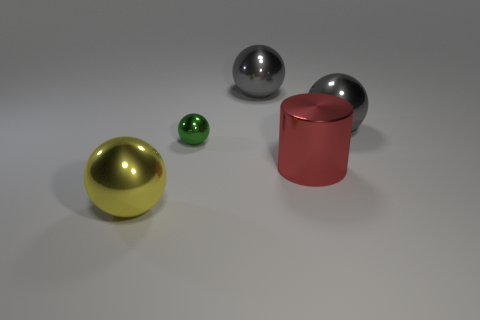How does the lighting in the image affect the appearance of the objects? The lighting from above creates subtle highlights and shadows on the objects, enhancing their three-dimensionality. It particularly accentuates the metallic sheen of the spheres and cylinder and provides a soft contrast on the matte surface of the green object. 